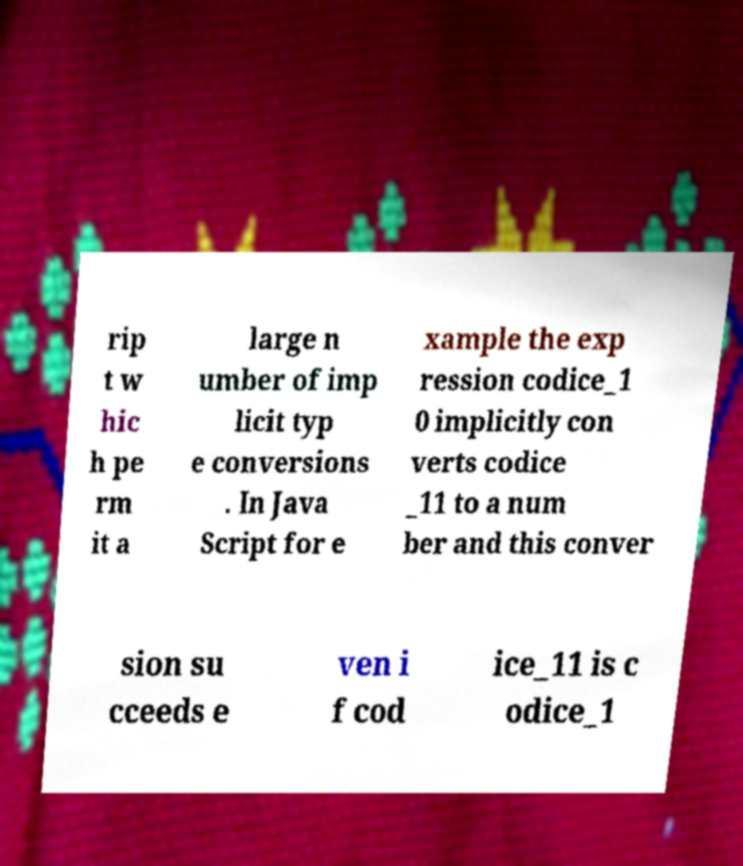Please identify and transcribe the text found in this image. rip t w hic h pe rm it a large n umber of imp licit typ e conversions . In Java Script for e xample the exp ression codice_1 0 implicitly con verts codice _11 to a num ber and this conver sion su cceeds e ven i f cod ice_11 is c odice_1 